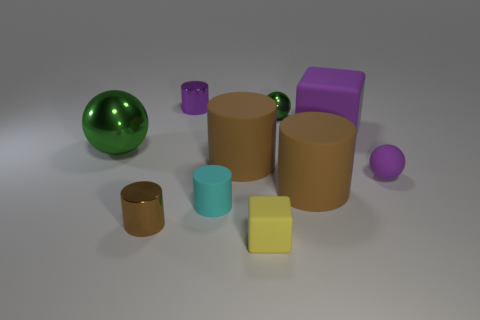Subtract all red balls. How many brown cylinders are left? 3 Subtract all tiny rubber cylinders. How many cylinders are left? 4 Subtract all cyan cylinders. How many cylinders are left? 4 Subtract all gray cylinders. Subtract all green blocks. How many cylinders are left? 5 Subtract all balls. How many objects are left? 7 Subtract all gray shiny cylinders. Subtract all rubber things. How many objects are left? 4 Add 3 tiny spheres. How many tiny spheres are left? 5 Add 2 tiny purple cylinders. How many tiny purple cylinders exist? 3 Subtract 0 red cylinders. How many objects are left? 10 